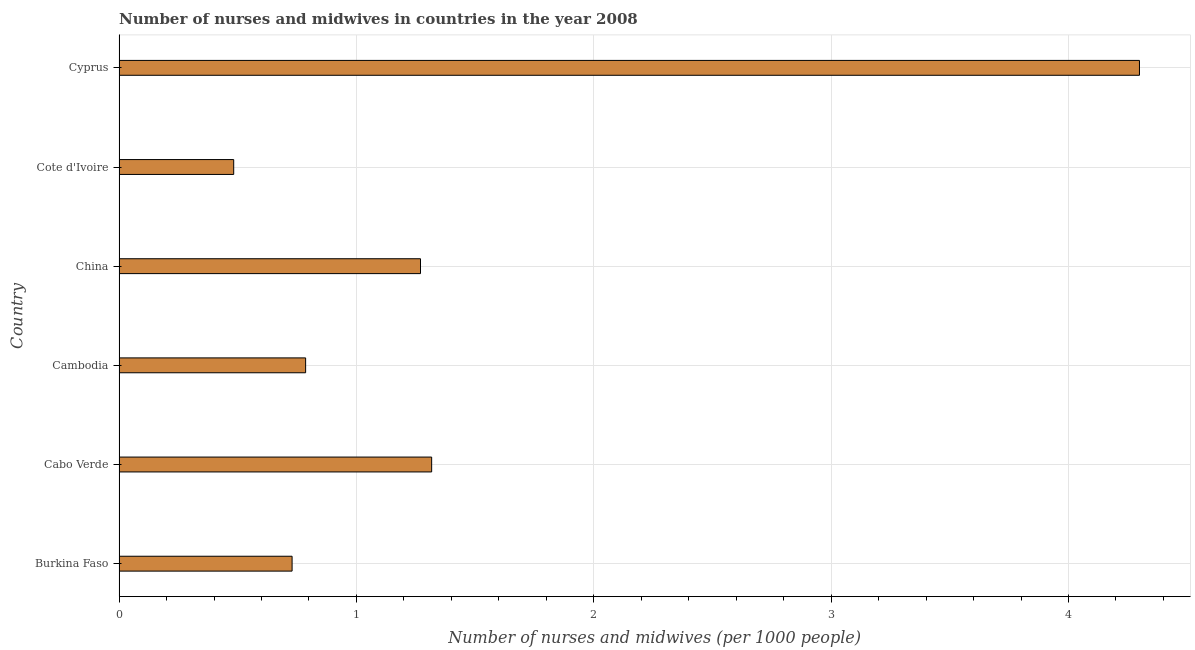Does the graph contain any zero values?
Provide a succinct answer. No. Does the graph contain grids?
Provide a short and direct response. Yes. What is the title of the graph?
Make the answer very short. Number of nurses and midwives in countries in the year 2008. What is the label or title of the X-axis?
Make the answer very short. Number of nurses and midwives (per 1000 people). What is the label or title of the Y-axis?
Make the answer very short. Country. What is the number of nurses and midwives in Burkina Faso?
Offer a very short reply. 0.73. Across all countries, what is the maximum number of nurses and midwives?
Provide a short and direct response. 4.3. Across all countries, what is the minimum number of nurses and midwives?
Provide a short and direct response. 0.48. In which country was the number of nurses and midwives maximum?
Offer a very short reply. Cyprus. In which country was the number of nurses and midwives minimum?
Your response must be concise. Cote d'Ivoire. What is the sum of the number of nurses and midwives?
Make the answer very short. 8.88. What is the difference between the number of nurses and midwives in Cabo Verde and Cote d'Ivoire?
Your answer should be compact. 0.83. What is the average number of nurses and midwives per country?
Keep it short and to the point. 1.48. What is the median number of nurses and midwives?
Offer a terse response. 1.03. What is the ratio of the number of nurses and midwives in Cote d'Ivoire to that in Cyprus?
Provide a succinct answer. 0.11. Is the number of nurses and midwives in Burkina Faso less than that in Cabo Verde?
Give a very brief answer. Yes. What is the difference between the highest and the second highest number of nurses and midwives?
Give a very brief answer. 2.98. Is the sum of the number of nurses and midwives in China and Cyprus greater than the maximum number of nurses and midwives across all countries?
Your answer should be compact. Yes. What is the difference between the highest and the lowest number of nurses and midwives?
Provide a succinct answer. 3.82. How many bars are there?
Ensure brevity in your answer.  6. Are all the bars in the graph horizontal?
Your answer should be very brief. Yes. How many countries are there in the graph?
Offer a very short reply. 6. What is the difference between two consecutive major ticks on the X-axis?
Your answer should be very brief. 1. What is the Number of nurses and midwives (per 1000 people) in Burkina Faso?
Your answer should be very brief. 0.73. What is the Number of nurses and midwives (per 1000 people) of Cabo Verde?
Your answer should be very brief. 1.32. What is the Number of nurses and midwives (per 1000 people) of Cambodia?
Provide a succinct answer. 0.79. What is the Number of nurses and midwives (per 1000 people) of China?
Provide a short and direct response. 1.27. What is the Number of nurses and midwives (per 1000 people) in Cote d'Ivoire?
Provide a succinct answer. 0.48. What is the Number of nurses and midwives (per 1000 people) in Cyprus?
Offer a terse response. 4.3. What is the difference between the Number of nurses and midwives (per 1000 people) in Burkina Faso and Cabo Verde?
Keep it short and to the point. -0.59. What is the difference between the Number of nurses and midwives (per 1000 people) in Burkina Faso and Cambodia?
Your answer should be compact. -0.06. What is the difference between the Number of nurses and midwives (per 1000 people) in Burkina Faso and China?
Ensure brevity in your answer.  -0.54. What is the difference between the Number of nurses and midwives (per 1000 people) in Burkina Faso and Cote d'Ivoire?
Make the answer very short. 0.25. What is the difference between the Number of nurses and midwives (per 1000 people) in Burkina Faso and Cyprus?
Make the answer very short. -3.57. What is the difference between the Number of nurses and midwives (per 1000 people) in Cabo Verde and Cambodia?
Provide a short and direct response. 0.53. What is the difference between the Number of nurses and midwives (per 1000 people) in Cabo Verde and China?
Provide a succinct answer. 0.05. What is the difference between the Number of nurses and midwives (per 1000 people) in Cabo Verde and Cote d'Ivoire?
Offer a very short reply. 0.83. What is the difference between the Number of nurses and midwives (per 1000 people) in Cabo Verde and Cyprus?
Give a very brief answer. -2.98. What is the difference between the Number of nurses and midwives (per 1000 people) in Cambodia and China?
Give a very brief answer. -0.48. What is the difference between the Number of nurses and midwives (per 1000 people) in Cambodia and Cote d'Ivoire?
Ensure brevity in your answer.  0.3. What is the difference between the Number of nurses and midwives (per 1000 people) in Cambodia and Cyprus?
Give a very brief answer. -3.51. What is the difference between the Number of nurses and midwives (per 1000 people) in China and Cote d'Ivoire?
Give a very brief answer. 0.79. What is the difference between the Number of nurses and midwives (per 1000 people) in China and Cyprus?
Give a very brief answer. -3.03. What is the difference between the Number of nurses and midwives (per 1000 people) in Cote d'Ivoire and Cyprus?
Ensure brevity in your answer.  -3.82. What is the ratio of the Number of nurses and midwives (per 1000 people) in Burkina Faso to that in Cabo Verde?
Offer a very short reply. 0.55. What is the ratio of the Number of nurses and midwives (per 1000 people) in Burkina Faso to that in Cambodia?
Your answer should be compact. 0.93. What is the ratio of the Number of nurses and midwives (per 1000 people) in Burkina Faso to that in China?
Your answer should be very brief. 0.57. What is the ratio of the Number of nurses and midwives (per 1000 people) in Burkina Faso to that in Cote d'Ivoire?
Make the answer very short. 1.51. What is the ratio of the Number of nurses and midwives (per 1000 people) in Burkina Faso to that in Cyprus?
Your answer should be compact. 0.17. What is the ratio of the Number of nurses and midwives (per 1000 people) in Cabo Verde to that in Cambodia?
Provide a succinct answer. 1.68. What is the ratio of the Number of nurses and midwives (per 1000 people) in Cabo Verde to that in China?
Provide a succinct answer. 1.04. What is the ratio of the Number of nurses and midwives (per 1000 people) in Cabo Verde to that in Cote d'Ivoire?
Give a very brief answer. 2.73. What is the ratio of the Number of nurses and midwives (per 1000 people) in Cabo Verde to that in Cyprus?
Keep it short and to the point. 0.31. What is the ratio of the Number of nurses and midwives (per 1000 people) in Cambodia to that in China?
Make the answer very short. 0.62. What is the ratio of the Number of nurses and midwives (per 1000 people) in Cambodia to that in Cote d'Ivoire?
Make the answer very short. 1.63. What is the ratio of the Number of nurses and midwives (per 1000 people) in Cambodia to that in Cyprus?
Provide a short and direct response. 0.18. What is the ratio of the Number of nurses and midwives (per 1000 people) in China to that in Cote d'Ivoire?
Give a very brief answer. 2.63. What is the ratio of the Number of nurses and midwives (per 1000 people) in China to that in Cyprus?
Give a very brief answer. 0.29. What is the ratio of the Number of nurses and midwives (per 1000 people) in Cote d'Ivoire to that in Cyprus?
Your response must be concise. 0.11. 